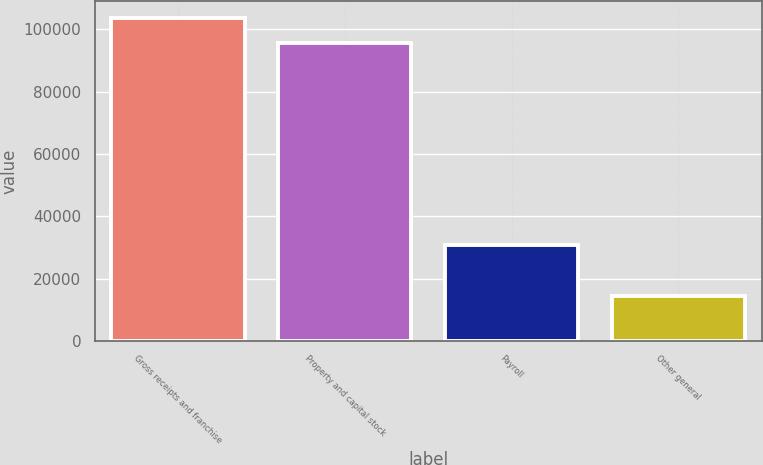Convert chart. <chart><loc_0><loc_0><loc_500><loc_500><bar_chart><fcel>Gross receipts and franchise<fcel>Property and capital stock<fcel>Payroll<fcel>Other general<nl><fcel>103816<fcel>95651<fcel>30698<fcel>14369<nl></chart> 